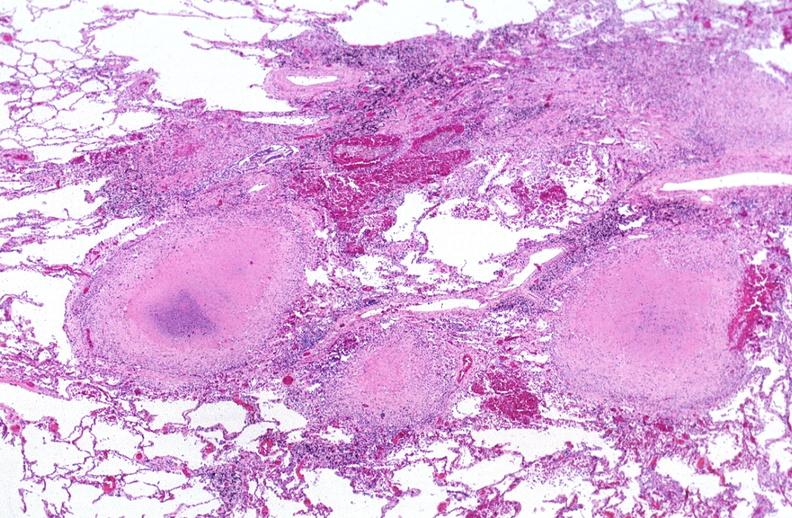does polycystic disease show lung, mycobacterium tuberculosis, granulomas and giant cells?
Answer the question using a single word or phrase. No 